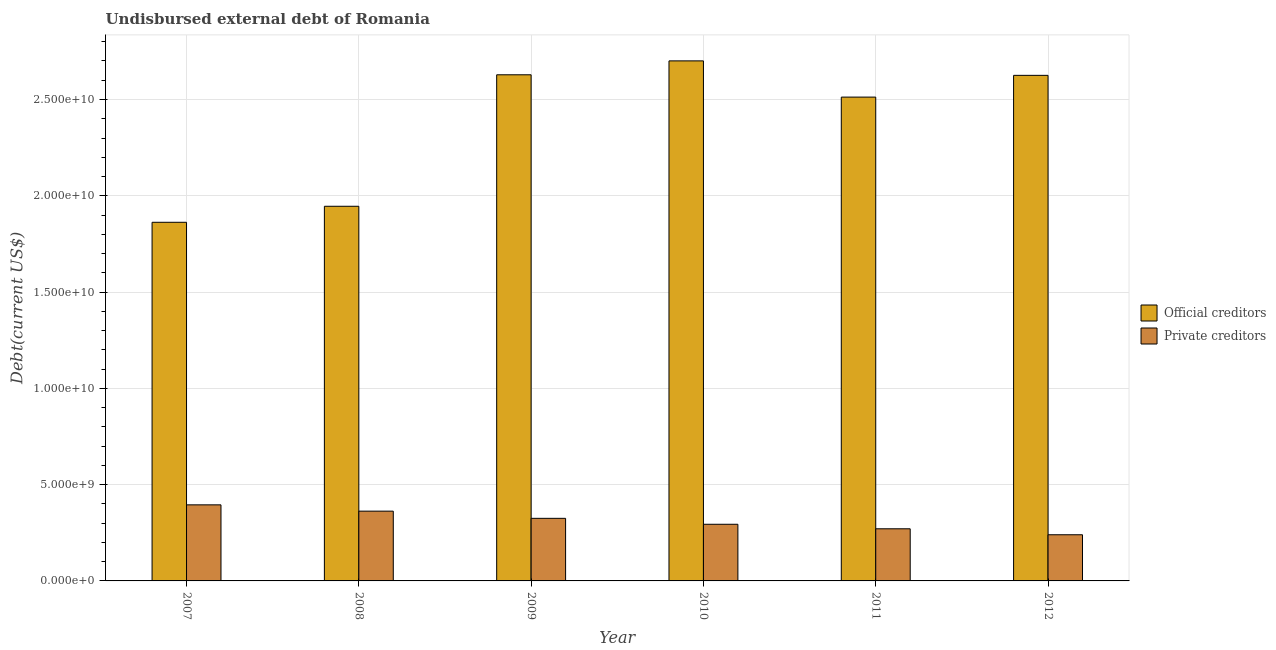Are the number of bars on each tick of the X-axis equal?
Make the answer very short. Yes. What is the undisbursed external debt of official creditors in 2007?
Your response must be concise. 1.86e+1. Across all years, what is the maximum undisbursed external debt of private creditors?
Your answer should be compact. 3.95e+09. Across all years, what is the minimum undisbursed external debt of private creditors?
Your answer should be very brief. 2.40e+09. In which year was the undisbursed external debt of official creditors maximum?
Offer a terse response. 2010. What is the total undisbursed external debt of official creditors in the graph?
Offer a very short reply. 1.43e+11. What is the difference between the undisbursed external debt of official creditors in 2008 and that in 2011?
Provide a succinct answer. -5.67e+09. What is the difference between the undisbursed external debt of official creditors in 2011 and the undisbursed external debt of private creditors in 2009?
Provide a short and direct response. -1.16e+09. What is the average undisbursed external debt of official creditors per year?
Provide a succinct answer. 2.38e+1. In the year 2011, what is the difference between the undisbursed external debt of official creditors and undisbursed external debt of private creditors?
Give a very brief answer. 0. What is the ratio of the undisbursed external debt of private creditors in 2009 to that in 2011?
Offer a very short reply. 1.2. What is the difference between the highest and the second highest undisbursed external debt of official creditors?
Offer a terse response. 7.22e+08. What is the difference between the highest and the lowest undisbursed external debt of private creditors?
Offer a terse response. 1.55e+09. Is the sum of the undisbursed external debt of private creditors in 2008 and 2011 greater than the maximum undisbursed external debt of official creditors across all years?
Offer a very short reply. Yes. What does the 1st bar from the left in 2012 represents?
Provide a succinct answer. Official creditors. What does the 1st bar from the right in 2010 represents?
Provide a succinct answer. Private creditors. How many bars are there?
Your response must be concise. 12. Are the values on the major ticks of Y-axis written in scientific E-notation?
Offer a terse response. Yes. Where does the legend appear in the graph?
Your answer should be very brief. Center right. How many legend labels are there?
Your response must be concise. 2. What is the title of the graph?
Ensure brevity in your answer.  Undisbursed external debt of Romania. What is the label or title of the X-axis?
Offer a terse response. Year. What is the label or title of the Y-axis?
Keep it short and to the point. Debt(current US$). What is the Debt(current US$) in Official creditors in 2007?
Give a very brief answer. 1.86e+1. What is the Debt(current US$) of Private creditors in 2007?
Offer a very short reply. 3.95e+09. What is the Debt(current US$) in Official creditors in 2008?
Ensure brevity in your answer.  1.95e+1. What is the Debt(current US$) in Private creditors in 2008?
Keep it short and to the point. 3.62e+09. What is the Debt(current US$) of Official creditors in 2009?
Offer a very short reply. 2.63e+1. What is the Debt(current US$) in Private creditors in 2009?
Offer a terse response. 3.25e+09. What is the Debt(current US$) in Official creditors in 2010?
Make the answer very short. 2.70e+1. What is the Debt(current US$) in Private creditors in 2010?
Give a very brief answer. 2.94e+09. What is the Debt(current US$) of Official creditors in 2011?
Your response must be concise. 2.51e+1. What is the Debt(current US$) in Private creditors in 2011?
Keep it short and to the point. 2.71e+09. What is the Debt(current US$) in Official creditors in 2012?
Keep it short and to the point. 2.63e+1. What is the Debt(current US$) in Private creditors in 2012?
Your response must be concise. 2.40e+09. Across all years, what is the maximum Debt(current US$) in Official creditors?
Make the answer very short. 2.70e+1. Across all years, what is the maximum Debt(current US$) in Private creditors?
Make the answer very short. 3.95e+09. Across all years, what is the minimum Debt(current US$) in Official creditors?
Your answer should be compact. 1.86e+1. Across all years, what is the minimum Debt(current US$) of Private creditors?
Your answer should be compact. 2.40e+09. What is the total Debt(current US$) in Official creditors in the graph?
Offer a terse response. 1.43e+11. What is the total Debt(current US$) in Private creditors in the graph?
Your answer should be compact. 1.89e+1. What is the difference between the Debt(current US$) of Official creditors in 2007 and that in 2008?
Make the answer very short. -8.32e+08. What is the difference between the Debt(current US$) of Private creditors in 2007 and that in 2008?
Your answer should be compact. 3.28e+08. What is the difference between the Debt(current US$) of Official creditors in 2007 and that in 2009?
Offer a very short reply. -7.66e+09. What is the difference between the Debt(current US$) in Private creditors in 2007 and that in 2009?
Make the answer very short. 7.01e+08. What is the difference between the Debt(current US$) in Official creditors in 2007 and that in 2010?
Give a very brief answer. -8.38e+09. What is the difference between the Debt(current US$) in Private creditors in 2007 and that in 2010?
Your answer should be compact. 1.01e+09. What is the difference between the Debt(current US$) in Official creditors in 2007 and that in 2011?
Offer a terse response. -6.50e+09. What is the difference between the Debt(current US$) in Private creditors in 2007 and that in 2011?
Your answer should be very brief. 1.24e+09. What is the difference between the Debt(current US$) in Official creditors in 2007 and that in 2012?
Your answer should be very brief. -7.63e+09. What is the difference between the Debt(current US$) of Private creditors in 2007 and that in 2012?
Your answer should be very brief. 1.55e+09. What is the difference between the Debt(current US$) in Official creditors in 2008 and that in 2009?
Ensure brevity in your answer.  -6.83e+09. What is the difference between the Debt(current US$) in Private creditors in 2008 and that in 2009?
Your response must be concise. 3.73e+08. What is the difference between the Debt(current US$) in Official creditors in 2008 and that in 2010?
Provide a succinct answer. -7.55e+09. What is the difference between the Debt(current US$) in Private creditors in 2008 and that in 2010?
Your response must be concise. 6.81e+08. What is the difference between the Debt(current US$) of Official creditors in 2008 and that in 2011?
Make the answer very short. -5.67e+09. What is the difference between the Debt(current US$) in Private creditors in 2008 and that in 2011?
Provide a succinct answer. 9.16e+08. What is the difference between the Debt(current US$) in Official creditors in 2008 and that in 2012?
Keep it short and to the point. -6.80e+09. What is the difference between the Debt(current US$) of Private creditors in 2008 and that in 2012?
Provide a short and direct response. 1.23e+09. What is the difference between the Debt(current US$) in Official creditors in 2009 and that in 2010?
Keep it short and to the point. -7.22e+08. What is the difference between the Debt(current US$) of Private creditors in 2009 and that in 2010?
Provide a succinct answer. 3.08e+08. What is the difference between the Debt(current US$) of Official creditors in 2009 and that in 2011?
Provide a short and direct response. 1.16e+09. What is the difference between the Debt(current US$) of Private creditors in 2009 and that in 2011?
Your answer should be compact. 5.43e+08. What is the difference between the Debt(current US$) of Official creditors in 2009 and that in 2012?
Your answer should be very brief. 2.95e+07. What is the difference between the Debt(current US$) of Private creditors in 2009 and that in 2012?
Give a very brief answer. 8.52e+08. What is the difference between the Debt(current US$) of Official creditors in 2010 and that in 2011?
Provide a short and direct response. 1.88e+09. What is the difference between the Debt(current US$) of Private creditors in 2010 and that in 2011?
Provide a succinct answer. 2.35e+08. What is the difference between the Debt(current US$) in Official creditors in 2010 and that in 2012?
Keep it short and to the point. 7.52e+08. What is the difference between the Debt(current US$) in Private creditors in 2010 and that in 2012?
Offer a very short reply. 5.45e+08. What is the difference between the Debt(current US$) of Official creditors in 2011 and that in 2012?
Your response must be concise. -1.13e+09. What is the difference between the Debt(current US$) in Private creditors in 2011 and that in 2012?
Keep it short and to the point. 3.09e+08. What is the difference between the Debt(current US$) of Official creditors in 2007 and the Debt(current US$) of Private creditors in 2008?
Give a very brief answer. 1.50e+1. What is the difference between the Debt(current US$) of Official creditors in 2007 and the Debt(current US$) of Private creditors in 2009?
Provide a succinct answer. 1.54e+1. What is the difference between the Debt(current US$) in Official creditors in 2007 and the Debt(current US$) in Private creditors in 2010?
Ensure brevity in your answer.  1.57e+1. What is the difference between the Debt(current US$) in Official creditors in 2007 and the Debt(current US$) in Private creditors in 2011?
Provide a short and direct response. 1.59e+1. What is the difference between the Debt(current US$) in Official creditors in 2007 and the Debt(current US$) in Private creditors in 2012?
Your answer should be compact. 1.62e+1. What is the difference between the Debt(current US$) of Official creditors in 2008 and the Debt(current US$) of Private creditors in 2009?
Keep it short and to the point. 1.62e+1. What is the difference between the Debt(current US$) in Official creditors in 2008 and the Debt(current US$) in Private creditors in 2010?
Provide a short and direct response. 1.65e+1. What is the difference between the Debt(current US$) in Official creditors in 2008 and the Debt(current US$) in Private creditors in 2011?
Provide a short and direct response. 1.67e+1. What is the difference between the Debt(current US$) of Official creditors in 2008 and the Debt(current US$) of Private creditors in 2012?
Provide a succinct answer. 1.71e+1. What is the difference between the Debt(current US$) in Official creditors in 2009 and the Debt(current US$) in Private creditors in 2010?
Provide a short and direct response. 2.33e+1. What is the difference between the Debt(current US$) in Official creditors in 2009 and the Debt(current US$) in Private creditors in 2011?
Provide a succinct answer. 2.36e+1. What is the difference between the Debt(current US$) of Official creditors in 2009 and the Debt(current US$) of Private creditors in 2012?
Your answer should be very brief. 2.39e+1. What is the difference between the Debt(current US$) in Official creditors in 2010 and the Debt(current US$) in Private creditors in 2011?
Give a very brief answer. 2.43e+1. What is the difference between the Debt(current US$) of Official creditors in 2010 and the Debt(current US$) of Private creditors in 2012?
Give a very brief answer. 2.46e+1. What is the difference between the Debt(current US$) in Official creditors in 2011 and the Debt(current US$) in Private creditors in 2012?
Ensure brevity in your answer.  2.27e+1. What is the average Debt(current US$) of Official creditors per year?
Give a very brief answer. 2.38e+1. What is the average Debt(current US$) of Private creditors per year?
Your answer should be very brief. 3.14e+09. In the year 2007, what is the difference between the Debt(current US$) of Official creditors and Debt(current US$) of Private creditors?
Offer a terse response. 1.47e+1. In the year 2008, what is the difference between the Debt(current US$) of Official creditors and Debt(current US$) of Private creditors?
Provide a succinct answer. 1.58e+1. In the year 2009, what is the difference between the Debt(current US$) in Official creditors and Debt(current US$) in Private creditors?
Your response must be concise. 2.30e+1. In the year 2010, what is the difference between the Debt(current US$) of Official creditors and Debt(current US$) of Private creditors?
Your response must be concise. 2.41e+1. In the year 2011, what is the difference between the Debt(current US$) in Official creditors and Debt(current US$) in Private creditors?
Your answer should be very brief. 2.24e+1. In the year 2012, what is the difference between the Debt(current US$) in Official creditors and Debt(current US$) in Private creditors?
Ensure brevity in your answer.  2.39e+1. What is the ratio of the Debt(current US$) of Official creditors in 2007 to that in 2008?
Offer a terse response. 0.96. What is the ratio of the Debt(current US$) in Private creditors in 2007 to that in 2008?
Your answer should be very brief. 1.09. What is the ratio of the Debt(current US$) of Official creditors in 2007 to that in 2009?
Provide a succinct answer. 0.71. What is the ratio of the Debt(current US$) of Private creditors in 2007 to that in 2009?
Provide a succinct answer. 1.22. What is the ratio of the Debt(current US$) of Official creditors in 2007 to that in 2010?
Offer a terse response. 0.69. What is the ratio of the Debt(current US$) in Private creditors in 2007 to that in 2010?
Your answer should be compact. 1.34. What is the ratio of the Debt(current US$) in Official creditors in 2007 to that in 2011?
Provide a succinct answer. 0.74. What is the ratio of the Debt(current US$) of Private creditors in 2007 to that in 2011?
Your answer should be compact. 1.46. What is the ratio of the Debt(current US$) of Official creditors in 2007 to that in 2012?
Offer a very short reply. 0.71. What is the ratio of the Debt(current US$) of Private creditors in 2007 to that in 2012?
Give a very brief answer. 1.65. What is the ratio of the Debt(current US$) of Official creditors in 2008 to that in 2009?
Provide a succinct answer. 0.74. What is the ratio of the Debt(current US$) in Private creditors in 2008 to that in 2009?
Provide a succinct answer. 1.11. What is the ratio of the Debt(current US$) of Official creditors in 2008 to that in 2010?
Your answer should be compact. 0.72. What is the ratio of the Debt(current US$) in Private creditors in 2008 to that in 2010?
Keep it short and to the point. 1.23. What is the ratio of the Debt(current US$) in Official creditors in 2008 to that in 2011?
Your answer should be compact. 0.77. What is the ratio of the Debt(current US$) in Private creditors in 2008 to that in 2011?
Make the answer very short. 1.34. What is the ratio of the Debt(current US$) in Official creditors in 2008 to that in 2012?
Make the answer very short. 0.74. What is the ratio of the Debt(current US$) of Private creditors in 2008 to that in 2012?
Offer a very short reply. 1.51. What is the ratio of the Debt(current US$) in Official creditors in 2009 to that in 2010?
Offer a very short reply. 0.97. What is the ratio of the Debt(current US$) in Private creditors in 2009 to that in 2010?
Your answer should be very brief. 1.1. What is the ratio of the Debt(current US$) in Official creditors in 2009 to that in 2011?
Offer a terse response. 1.05. What is the ratio of the Debt(current US$) in Private creditors in 2009 to that in 2011?
Offer a very short reply. 1.2. What is the ratio of the Debt(current US$) of Private creditors in 2009 to that in 2012?
Provide a succinct answer. 1.36. What is the ratio of the Debt(current US$) of Official creditors in 2010 to that in 2011?
Make the answer very short. 1.07. What is the ratio of the Debt(current US$) in Private creditors in 2010 to that in 2011?
Your answer should be very brief. 1.09. What is the ratio of the Debt(current US$) in Official creditors in 2010 to that in 2012?
Provide a short and direct response. 1.03. What is the ratio of the Debt(current US$) in Private creditors in 2010 to that in 2012?
Keep it short and to the point. 1.23. What is the ratio of the Debt(current US$) of Official creditors in 2011 to that in 2012?
Your answer should be compact. 0.96. What is the ratio of the Debt(current US$) in Private creditors in 2011 to that in 2012?
Your answer should be compact. 1.13. What is the difference between the highest and the second highest Debt(current US$) in Official creditors?
Ensure brevity in your answer.  7.22e+08. What is the difference between the highest and the second highest Debt(current US$) of Private creditors?
Keep it short and to the point. 3.28e+08. What is the difference between the highest and the lowest Debt(current US$) of Official creditors?
Provide a succinct answer. 8.38e+09. What is the difference between the highest and the lowest Debt(current US$) in Private creditors?
Your response must be concise. 1.55e+09. 